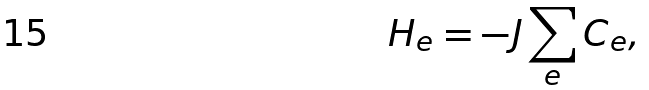<formula> <loc_0><loc_0><loc_500><loc_500>H _ { e } = - J \sum _ { e } C _ { e } ,</formula> 